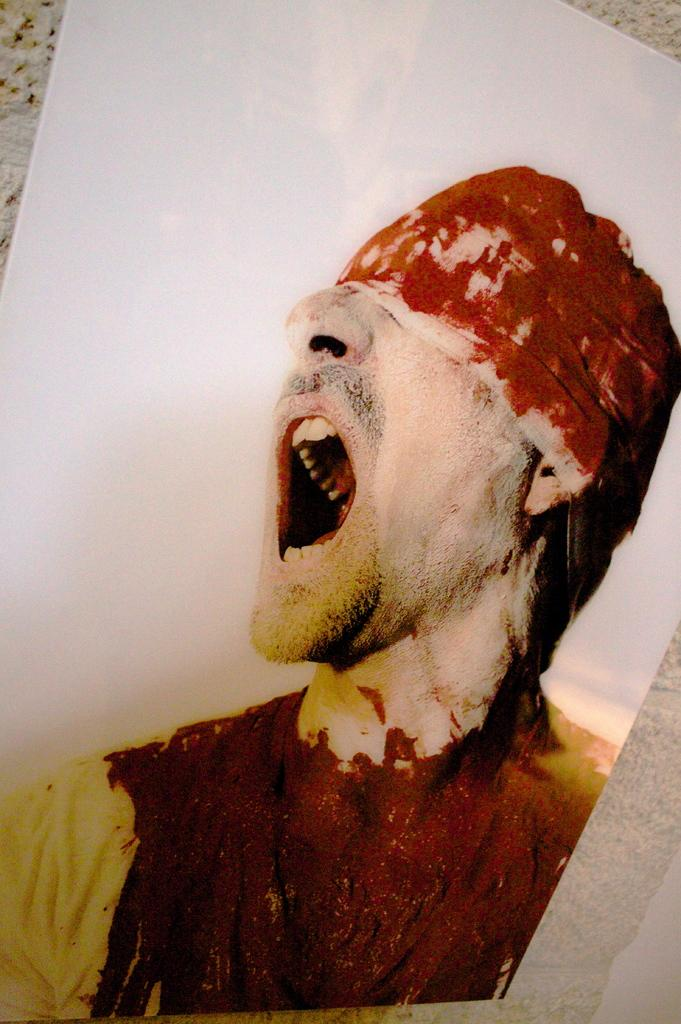What is the main subject of the image? There is a photograph in the image. What does the photograph depict? The photograph depicts an injured man. What can be seen on the injured man's head in the photograph? The injured man has a band over his head. Where is the photograph located in the image? The photograph is on a wall. What degree of damage can be seen on the table in the image? There is no table present in the image; it only features a photograph on a wall. 